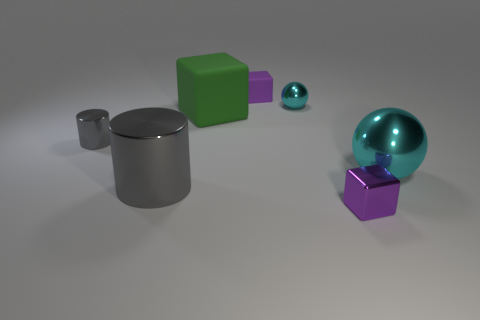There is a block in front of the tiny metallic thing that is left of the large gray metal cylinder; what is its size?
Provide a succinct answer. Small. Do the ball in front of the tiny cyan object and the tiny metallic thing that is behind the large green rubber object have the same color?
Provide a succinct answer. Yes. There is a purple thing that is in front of the sphere that is in front of the green cube; how many purple matte blocks are to the right of it?
Your answer should be compact. 0. What number of things are both in front of the large cyan ball and left of the tiny metal cube?
Your answer should be compact. 1. Are there more large objects to the left of the large cyan metallic object than tiny cylinders?
Offer a very short reply. Yes. How many metallic objects have the same size as the purple rubber block?
Offer a very short reply. 3. There is another metallic cylinder that is the same color as the large metallic cylinder; what is its size?
Your response must be concise. Small. How many big objects are either green things or yellow matte cylinders?
Ensure brevity in your answer.  1. What number of gray cylinders are there?
Give a very brief answer. 2. Is the number of big cyan objects behind the tiny cyan metallic object the same as the number of small things in front of the tiny gray thing?
Give a very brief answer. No. 